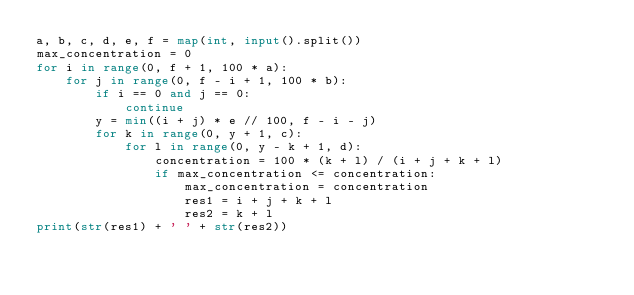<code> <loc_0><loc_0><loc_500><loc_500><_Python_>a, b, c, d, e, f = map(int, input().split())
max_concentration = 0
for i in range(0, f + 1, 100 * a):
    for j in range(0, f - i + 1, 100 * b):
        if i == 0 and j == 0:
            continue
        y = min((i + j) * e // 100, f - i - j)
        for k in range(0, y + 1, c):
            for l in range(0, y - k + 1, d):
                concentration = 100 * (k + l) / (i + j + k + l)
                if max_concentration <= concentration:
                    max_concentration = concentration
                    res1 = i + j + k + l
                    res2 = k + l
print(str(res1) + ' ' + str(res2))
</code> 